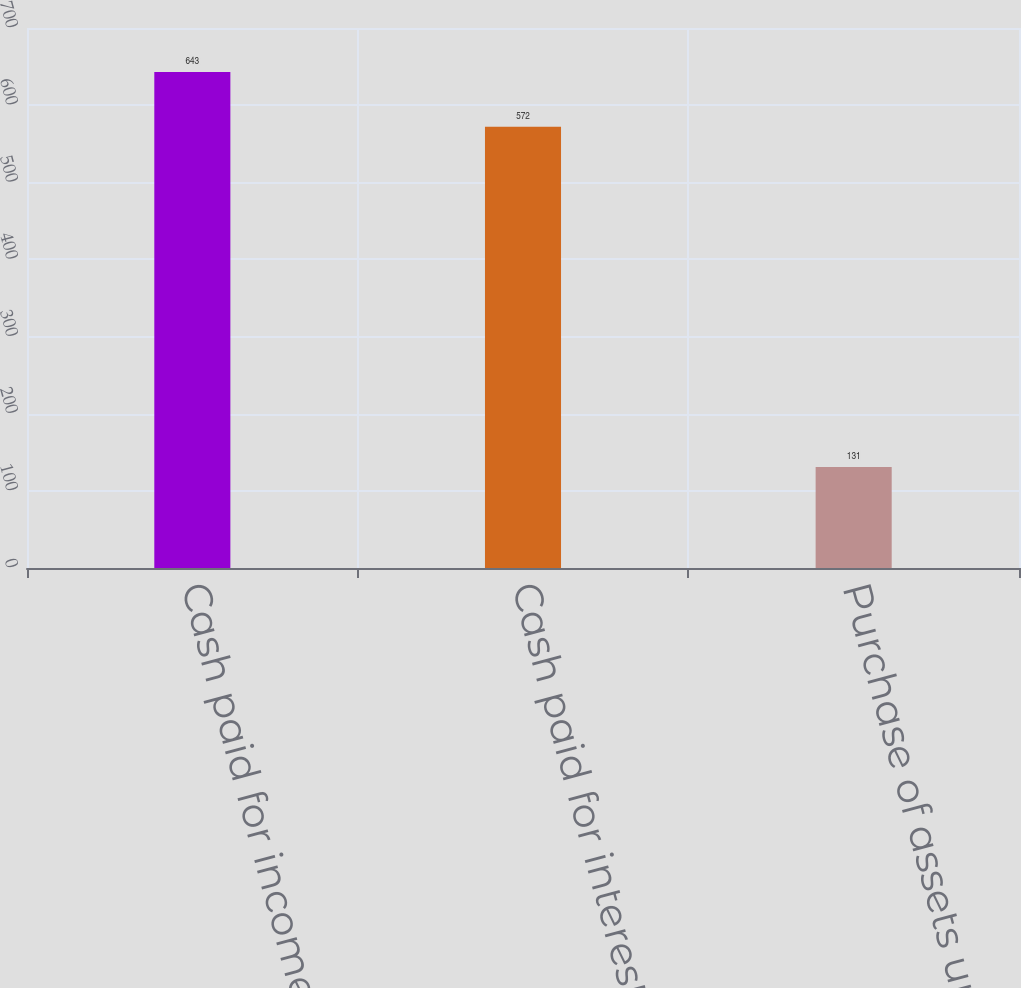Convert chart to OTSL. <chart><loc_0><loc_0><loc_500><loc_500><bar_chart><fcel>Cash paid for income taxes net<fcel>Cash paid for interest<fcel>Purchase of assets under<nl><fcel>643<fcel>572<fcel>131<nl></chart> 